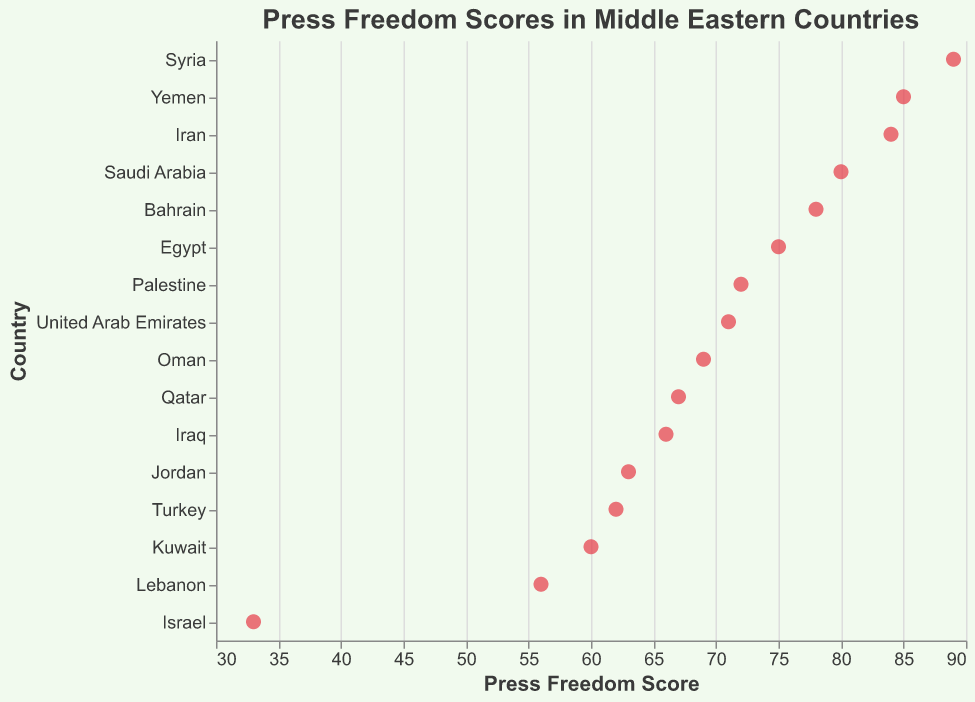What is the Press Freedom Score for Iran? The Press Freedom Score for Iran can be directly read from the figure. It shows that Iran has a Press Freedom Score of 84.
Answer: 84 Which country has the best (lowest) Press Freedom Score? By examining the positioning of the data points, the country with the lowest Press Freedom Score is Israel, which is at 33.
Answer: Israel How many countries have a Press Freedom Score above 70? Identify the number of data points that are positioned above the 70 mark on the horizontal axis. The countries are Iran, Saudi Arabia, Syria, Yemen, Egypt, Bahrain, and Palestine.
Answer: 7 What is the average Press Freedom Score of the Middle Eastern countries in this plot? Sum all the Press Freedom Scores and divide by the number of countries. The sum is 84 + 80 + 89 + 85 + 62 + 75 + 56 + 63 + 71 + 67 + 69 + 60 + 78 + 33 + 72 + 66 = 1160. There are 16 countries, so the average score is 1160 / 16.
Answer: 72.5 Which countries have a Press Freedom Score within 5 points of Iran's score? Iran's score is 84. Countries with scores within 5 points of 84 are Saudi Arabia (80), Syria (89), and Yemen (85).
Answer: Saudi Arabia, Syria, Yemen How does the Press Freedom Score of Lebanon compare to that of Kuwait? Look at the data points for Lebanon and Kuwait. Lebanon has a score of 56, while Kuwait has a score of 60. Lebanon's score is lower than Kuwait's.
Answer: Lebanon's score is lower What is the range of Press Freedom Scores in the Middle Eastern countries? The range is calculated by subtracting the smallest score from the largest score. The smallest score is for Israel (33), and the largest is for Syria (89). Thus, the range is 89 - 33.
Answer: 56 Do more countries have scores above or below 65? Count countries with scores above 65 and below 65. Above 65: Iran, Saudi Arabia, Syria, Yemen, Egypt, Bahrain, United Arab Emirates, Palestine, and Qatar (9 countries). Below 65: Turkey, Lebanon, Jordan, Kuwait, and Israel (5 countries). More countries have scores above 65.
Answer: Above 65 Which country has the closest Press Freedom Score to Turkey? Find the country with the score nearest to Turkey's score of 62. Jordan has a score of 63, which is the closest.
Answer: Jordan Is there any country with a Press Freedom Score equal to the average score of all countries? The average Press Freedom Score is 72.5. No country's score exactly matches this value; Palestine is the closest with a score of 72.
Answer: No 